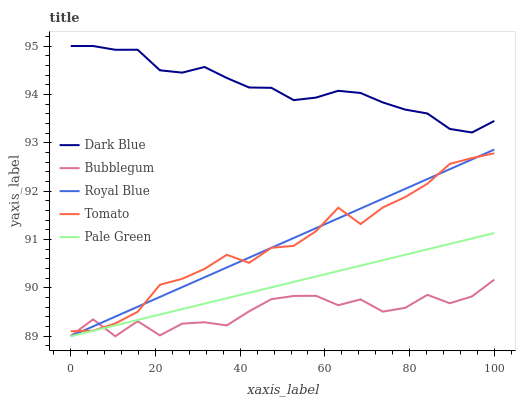Does Bubblegum have the minimum area under the curve?
Answer yes or no. Yes. Does Dark Blue have the maximum area under the curve?
Answer yes or no. Yes. Does Pale Green have the minimum area under the curve?
Answer yes or no. No. Does Pale Green have the maximum area under the curve?
Answer yes or no. No. Is Pale Green the smoothest?
Answer yes or no. Yes. Is Bubblegum the roughest?
Answer yes or no. Yes. Is Dark Blue the smoothest?
Answer yes or no. No. Is Dark Blue the roughest?
Answer yes or no. No. Does Pale Green have the lowest value?
Answer yes or no. Yes. Does Dark Blue have the lowest value?
Answer yes or no. No. Does Dark Blue have the highest value?
Answer yes or no. Yes. Does Pale Green have the highest value?
Answer yes or no. No. Is Pale Green less than Tomato?
Answer yes or no. Yes. Is Dark Blue greater than Royal Blue?
Answer yes or no. Yes. Does Pale Green intersect Royal Blue?
Answer yes or no. Yes. Is Pale Green less than Royal Blue?
Answer yes or no. No. Is Pale Green greater than Royal Blue?
Answer yes or no. No. Does Pale Green intersect Tomato?
Answer yes or no. No. 